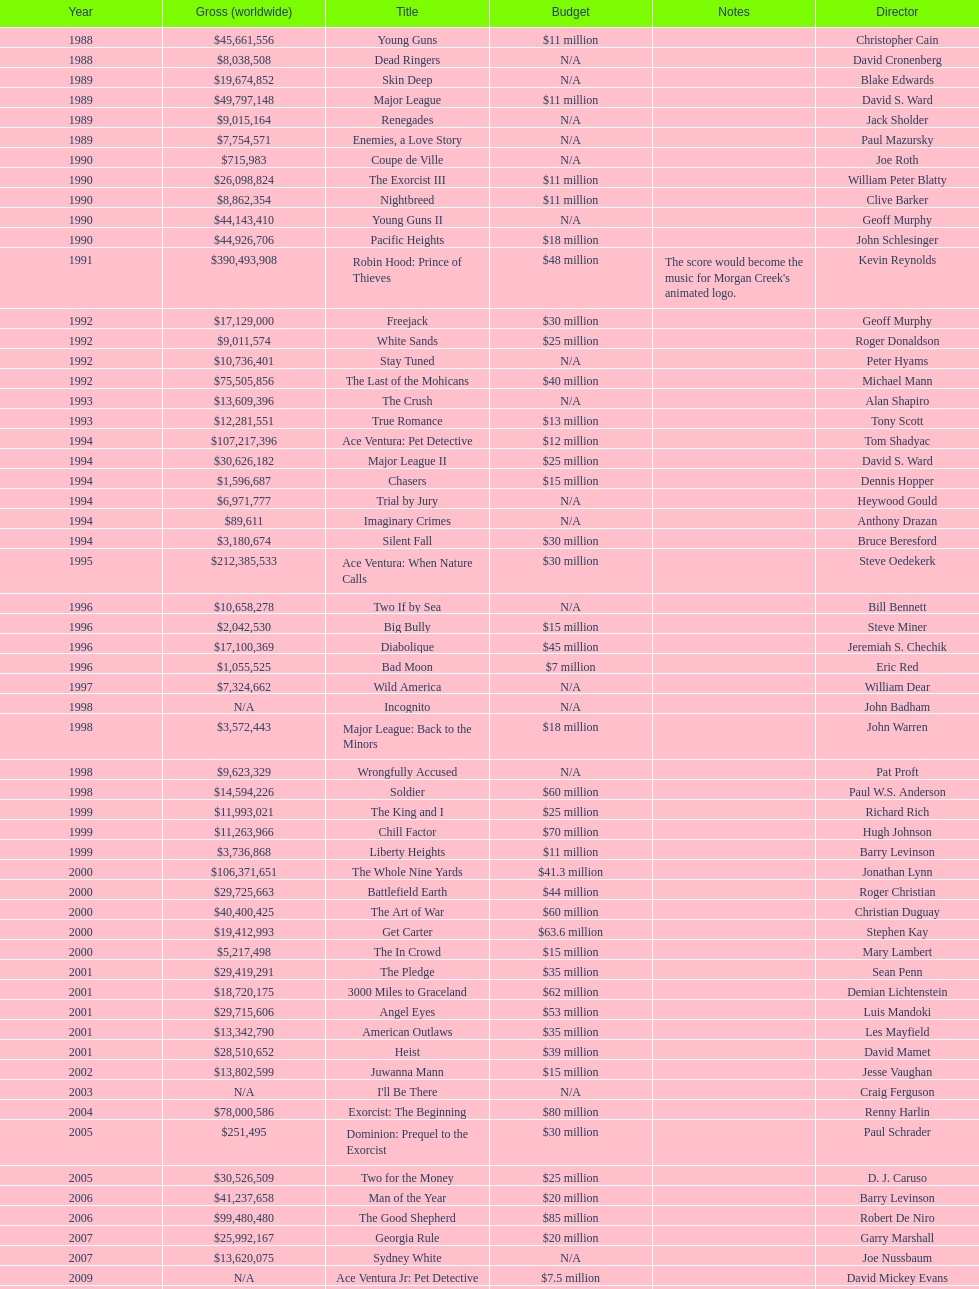Which film had a higher budget, ace ventura: when nature calls, or major league: back to the minors? Ace Ventura: When Nature Calls. 